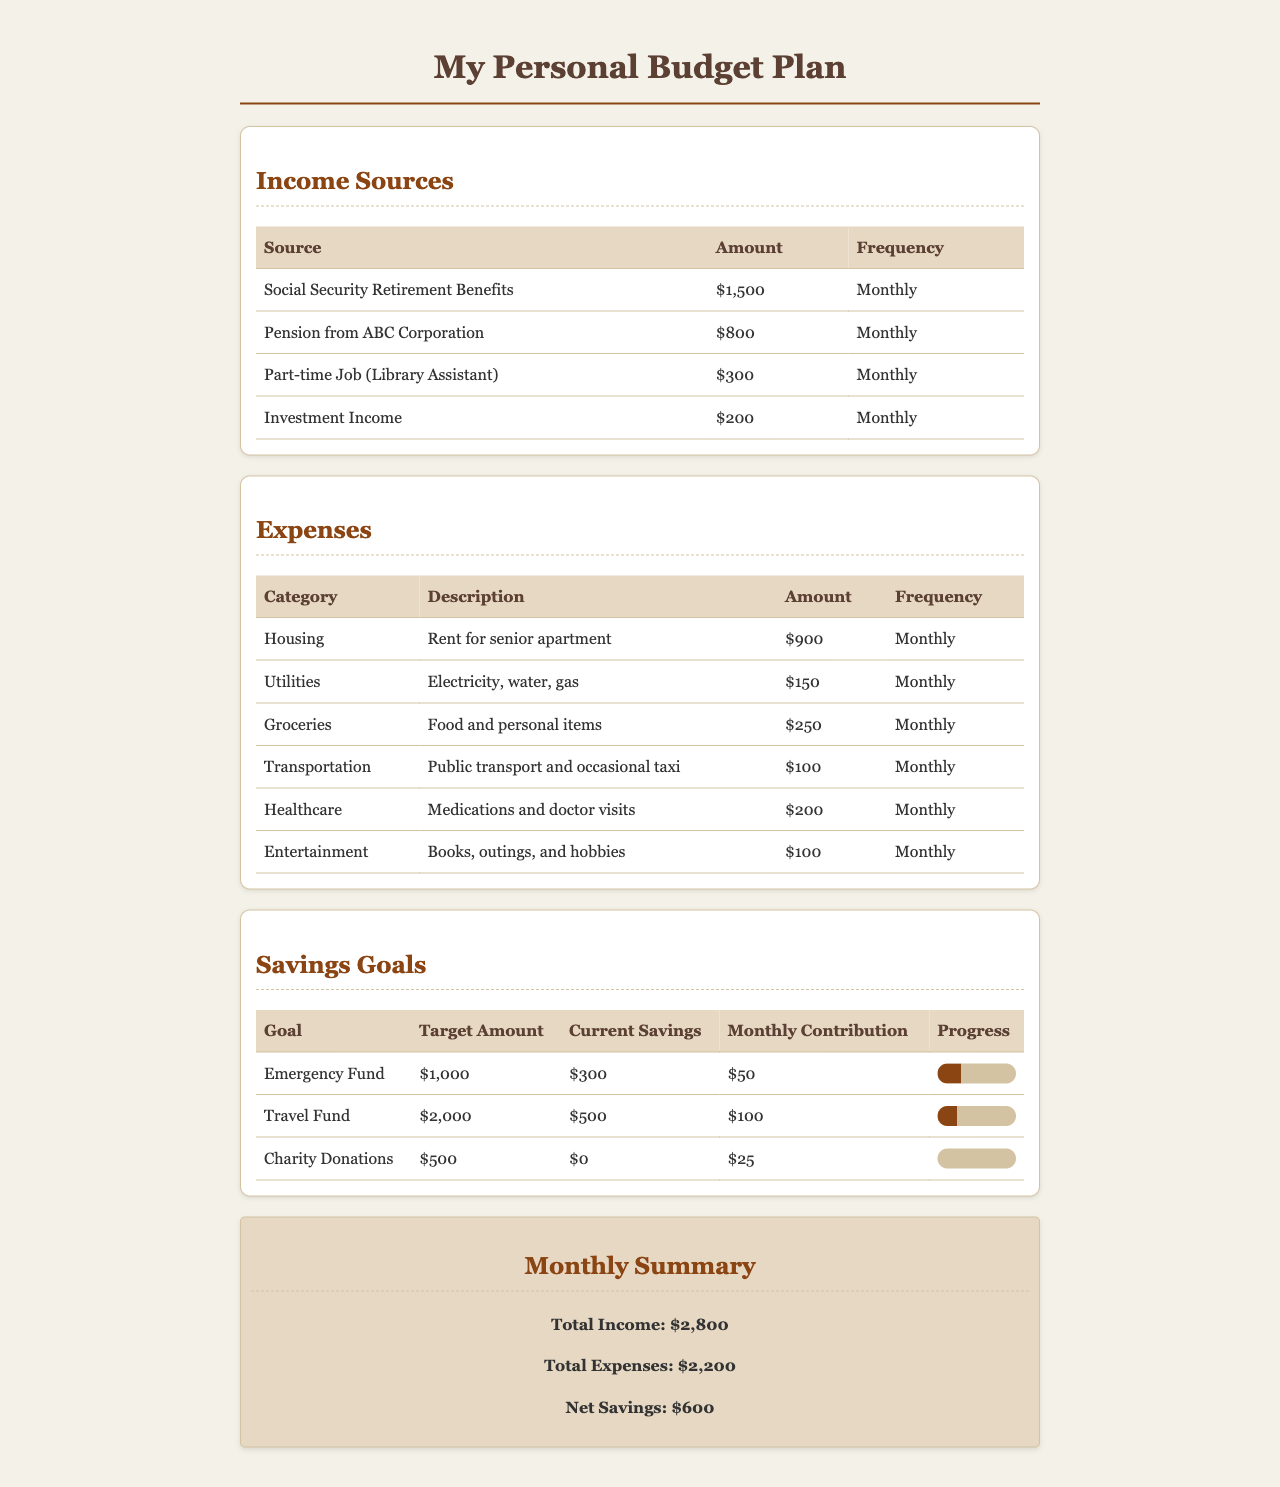What is the total income? The total income is calculated by summing all income sources listed in the document, which amounts to $1,500 + $800 + $300 + $200 = $2,800.
Answer: $2,800 How much is allocated for healthcare expenses? The document specifies the amount set aside for healthcare expenses, which is $200 monthly.
Answer: $200 What is the target amount for the travel fund? The target amount for the travel fund is explicitly stated in the document as $2,000.
Answer: $2,000 What is the net savings reported in the monthly summary? The net savings is determined by subtracting total expenses from total income, showing a net savings of $600 in the summary.
Answer: $600 Which income source has the highest amount listed? The income source with the highest amount is Social Security Retirement Benefits, which is $1,500.
Answer: $1,500 